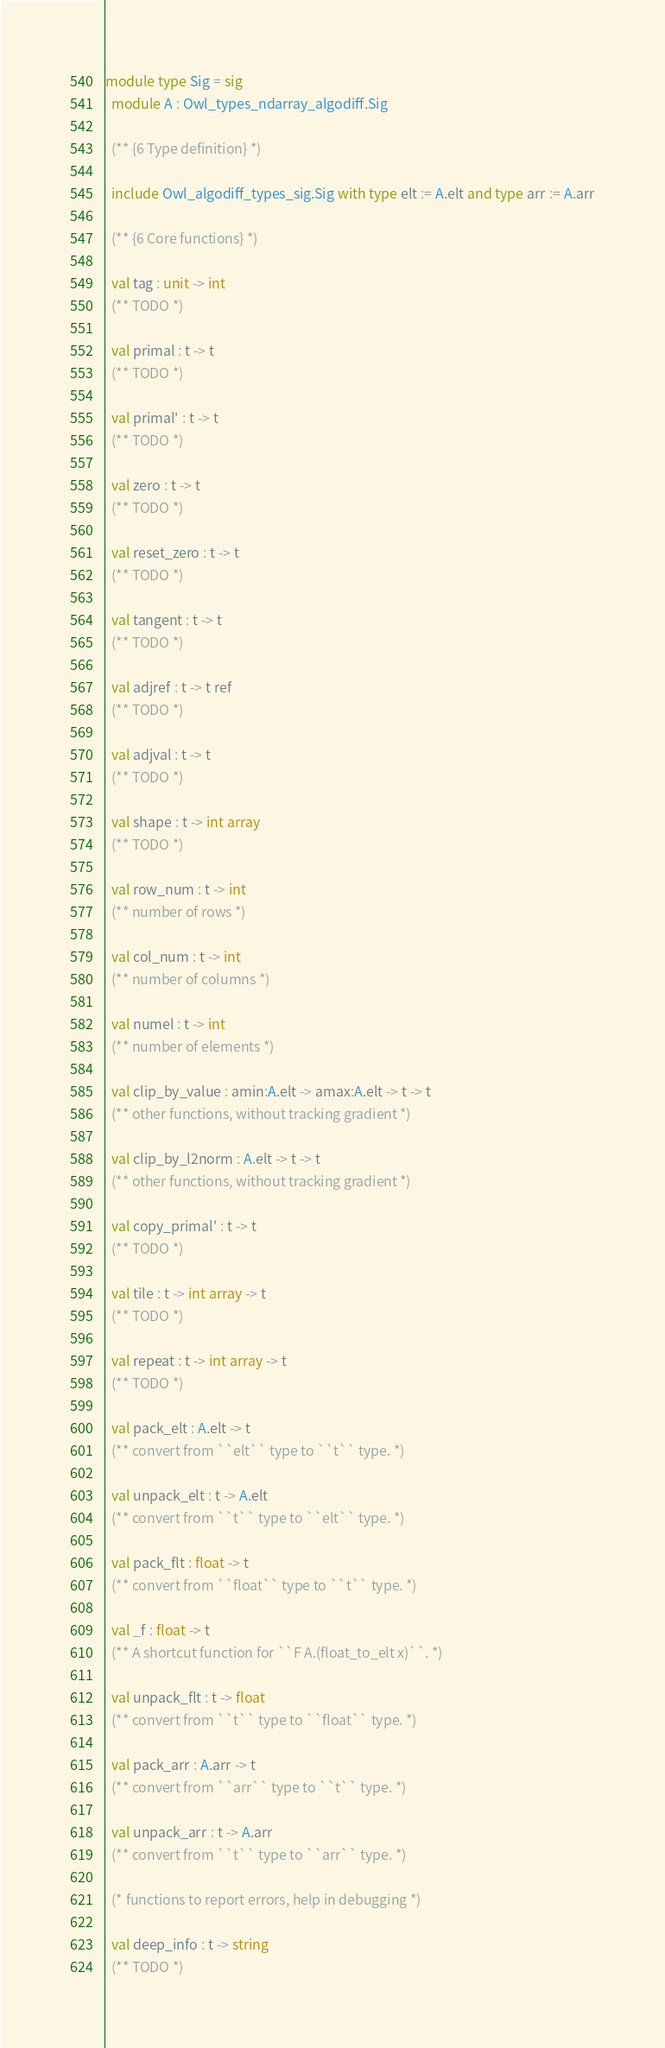<code> <loc_0><loc_0><loc_500><loc_500><_OCaml_>module type Sig = sig
  module A : Owl_types_ndarray_algodiff.Sig

  (** {6 Type definition} *)

  include Owl_algodiff_types_sig.Sig with type elt := A.elt and type arr := A.arr

  (** {6 Core functions} *)

  val tag : unit -> int
  (** TODO *)

  val primal : t -> t
  (** TODO *)

  val primal' : t -> t
  (** TODO *)

  val zero : t -> t
  (** TODO *)

  val reset_zero : t -> t
  (** TODO *)

  val tangent : t -> t
  (** TODO *)

  val adjref : t -> t ref
  (** TODO *)

  val adjval : t -> t
  (** TODO *)

  val shape : t -> int array
  (** TODO *)

  val row_num : t -> int
  (** number of rows *)

  val col_num : t -> int
  (** number of columns *)

  val numel : t -> int
  (** number of elements *)

  val clip_by_value : amin:A.elt -> amax:A.elt -> t -> t
  (** other functions, without tracking gradient *)

  val clip_by_l2norm : A.elt -> t -> t
  (** other functions, without tracking gradient *)

  val copy_primal' : t -> t
  (** TODO *)

  val tile : t -> int array -> t
  (** TODO *)

  val repeat : t -> int array -> t
  (** TODO *)

  val pack_elt : A.elt -> t
  (** convert from ``elt`` type to ``t`` type. *)

  val unpack_elt : t -> A.elt
  (** convert from ``t`` type to ``elt`` type. *)

  val pack_flt : float -> t
  (** convert from ``float`` type to ``t`` type. *)

  val _f : float -> t
  (** A shortcut function for ``F A.(float_to_elt x)``. *)

  val unpack_flt : t -> float
  (** convert from ``t`` type to ``float`` type. *)

  val pack_arr : A.arr -> t
  (** convert from ``arr`` type to ``t`` type. *)

  val unpack_arr : t -> A.arr
  (** convert from ``t`` type to ``arr`` type. *)

  (* functions to report errors, help in debugging *)

  val deep_info : t -> string
  (** TODO *)
</code> 